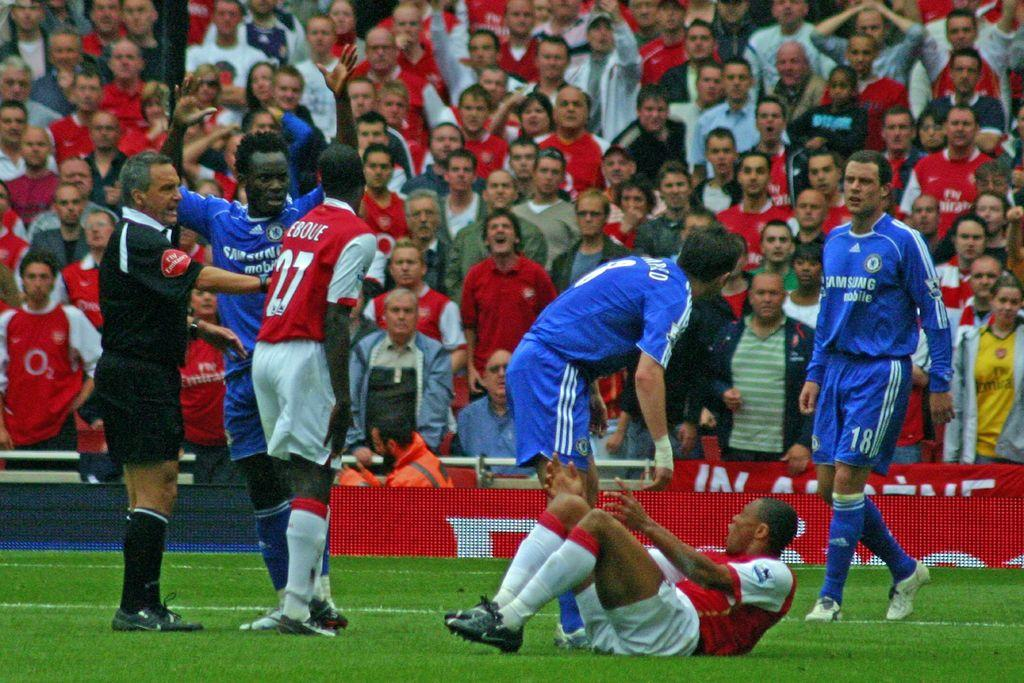<image>
Describe the image concisely. Player number 27 wears a red jersey and is talking to another player. 